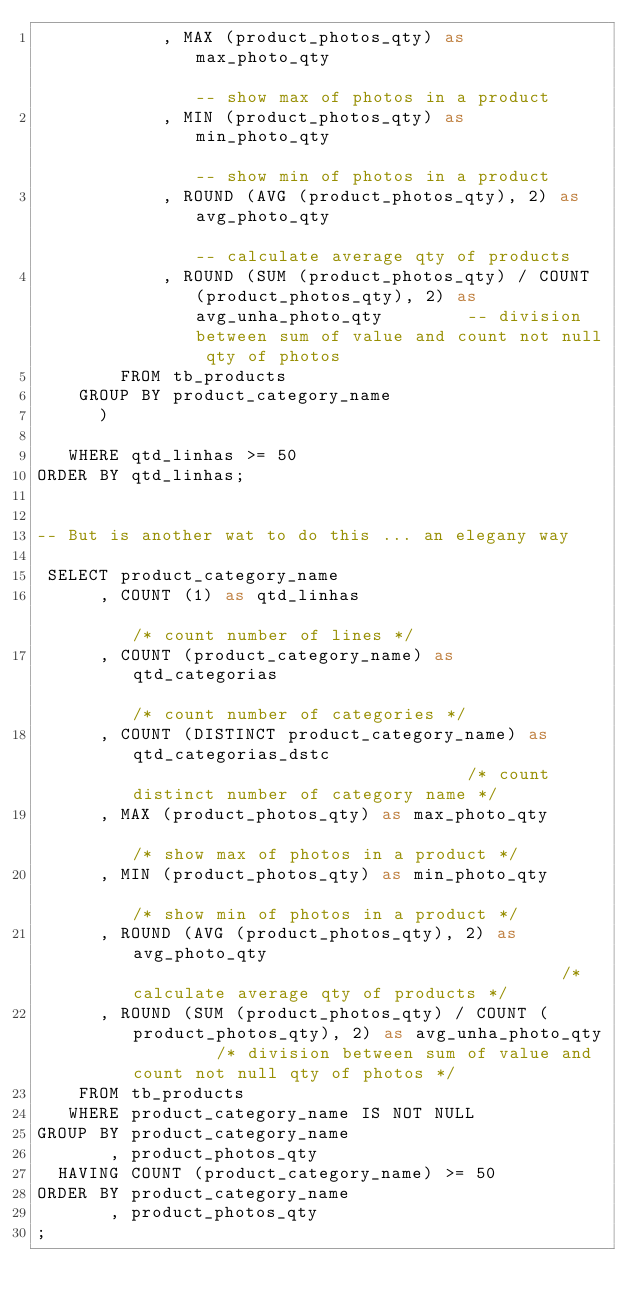Convert code to text. <code><loc_0><loc_0><loc_500><loc_500><_SQL_>            , MAX (product_photos_qty) as max_photo_qty                                                     -- show max of photos in a product
            , MIN (product_photos_qty) as min_photo_qty                                                     -- show min of photos in a product
            , ROUND (AVG (product_photos_qty), 2) as avg_photo_qty                                          -- calculate average qty of products
            , ROUND (SUM (product_photos_qty) / COUNT (product_photos_qty), 2) as avg_unha_photo_qty        -- division between sum of value and count not null qty of photos
        FROM tb_products
    GROUP BY product_category_name
      )
   
   WHERE qtd_linhas >= 50
ORDER BY qtd_linhas;


-- But is another wat to do this ... an elegany way

 SELECT product_category_name
      , COUNT (1) as qtd_linhas                                                                       /* count number of lines */
      , COUNT (product_category_name) as qtd_categorias                                               /* count number of categories */
      , COUNT (DISTINCT product_category_name) as qtd_categorias_dstc                                 /* count distinct number of category name */
      , MAX (product_photos_qty) as max_photo_qty                                                     /* show max of photos in a product */
      , MIN (product_photos_qty) as min_photo_qty                                                     /* show min of photos in a product */
      , ROUND (AVG (product_photos_qty), 2) as avg_photo_qty                                          /* calculate average qty of products */
      , ROUND (SUM (product_photos_qty) / COUNT (product_photos_qty), 2) as avg_unha_photo_qty        /* division between sum of value and count not null qty of photos */
    FROM tb_products
   WHERE product_category_name IS NOT NULL
GROUP BY product_category_name
       , product_photos_qty
  HAVING COUNT (product_category_name) >= 50
ORDER BY product_category_name
       , product_photos_qty
;
</code> 